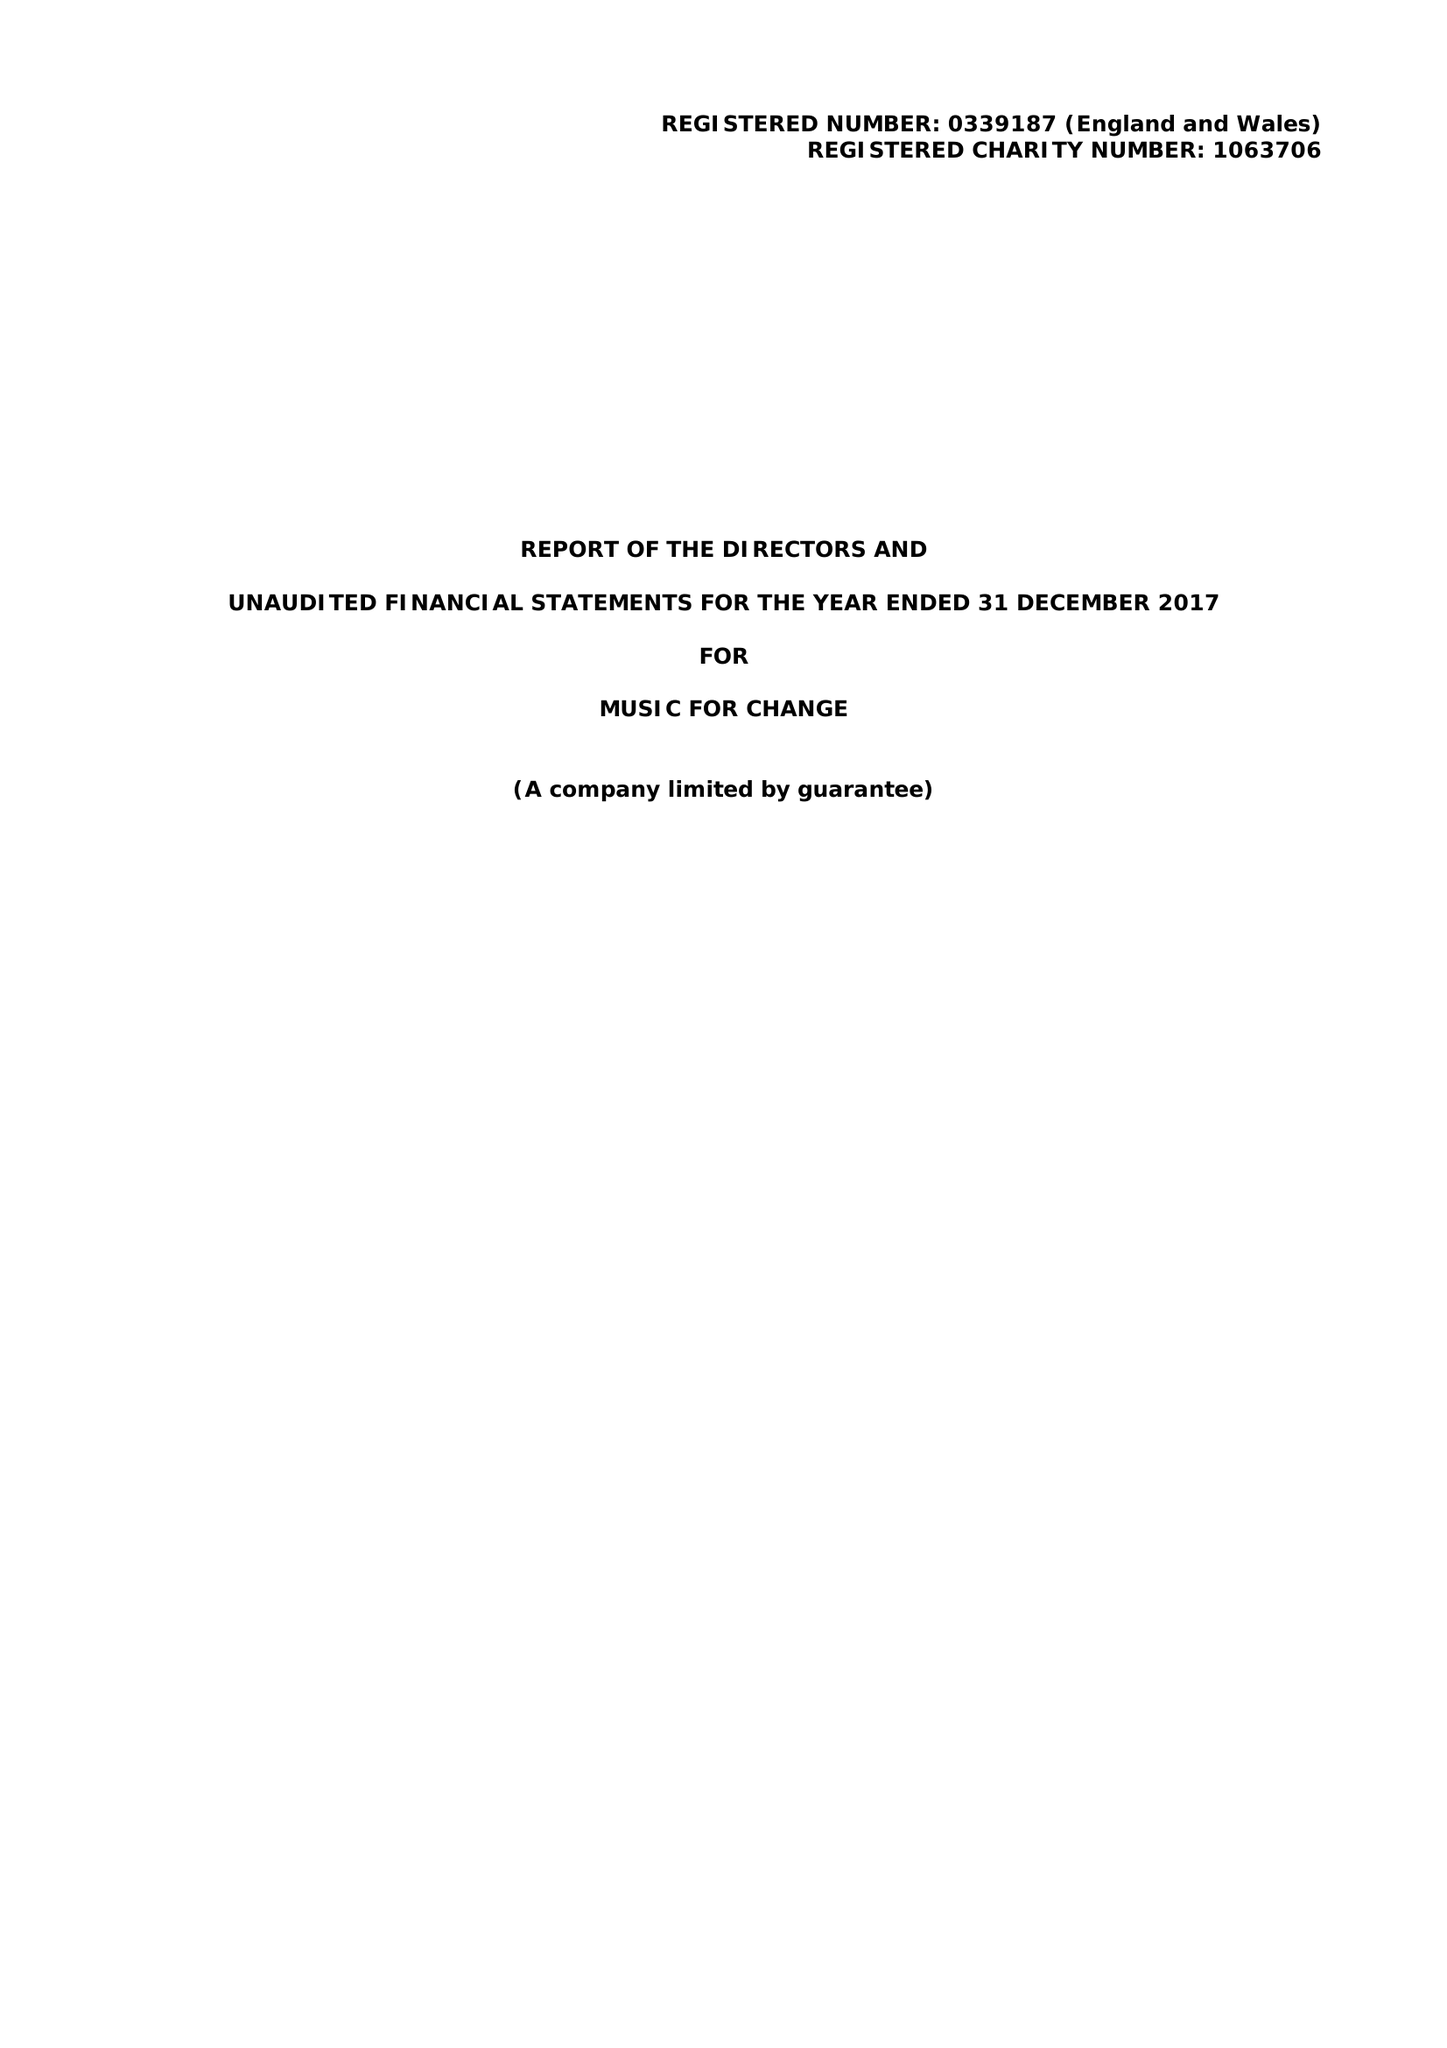What is the value for the charity_name?
Answer the question using a single word or phrase. Music For Change 